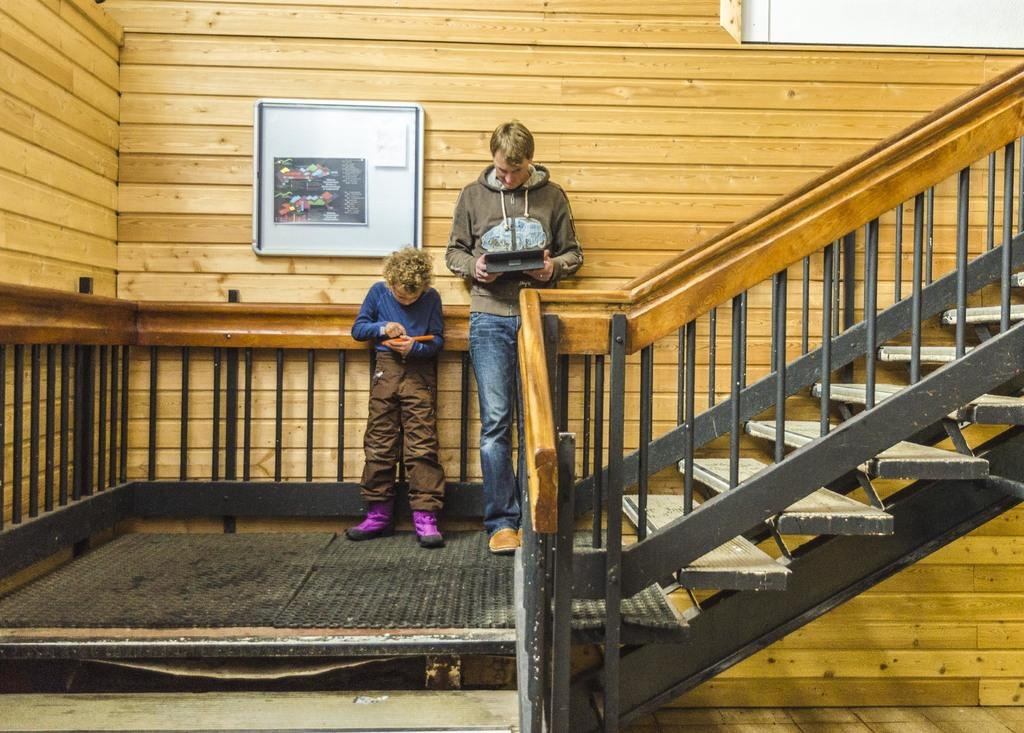How many people are in the image? There are people in the image, but the exact number is not specified. What are the people holding in the image? The people are holding objects in the image. What architectural feature is present in the image? There are stairs and railings present in the image. What is on the wall in the image? There is a board on the wall in the image. What type of decorations are visible in the image? There are posters visible in the image. What type of tray is being used to carry the crate in the image? There is no tray or crate present in the image. What surprise is hidden behind the posters in the image? There is no mention of a surprise or anything hidden behind the posters in the image. 